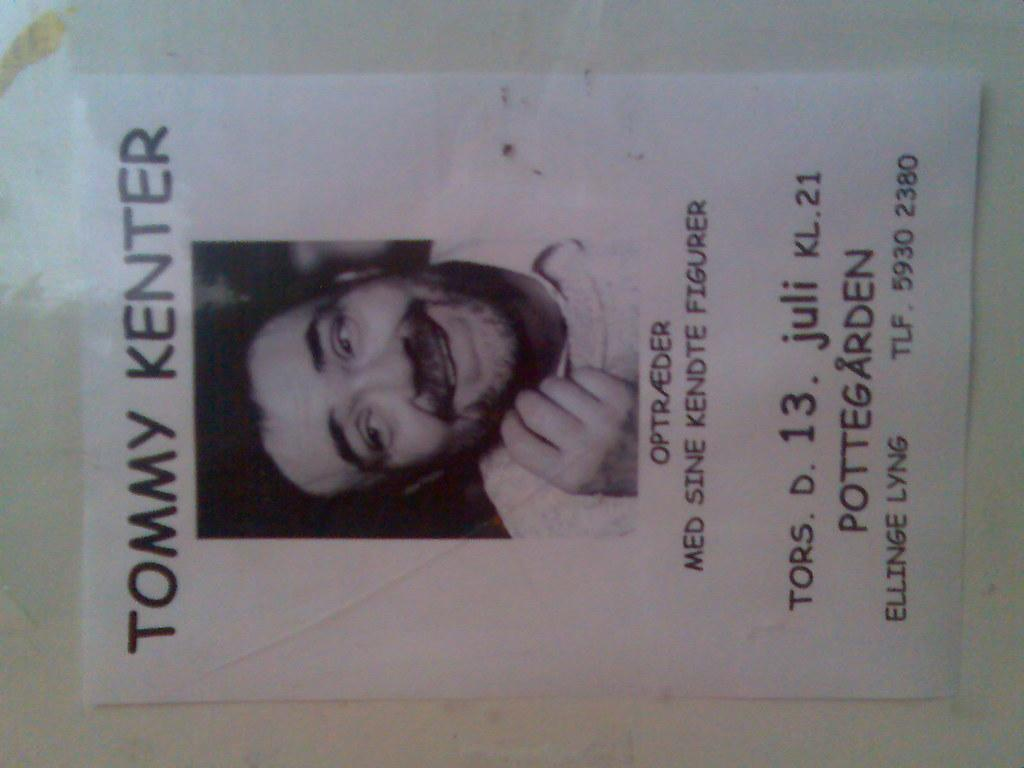<image>
Describe the image concisely. A photo of  a man named Tommy Kenter is on a homemade flyer that has been taped to a wall. 